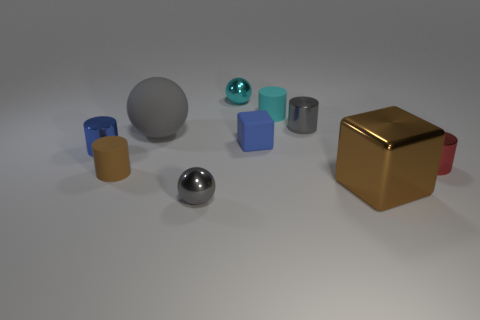What is the size of the matte thing that is on the left side of the small cyan metal ball and to the right of the small brown cylinder?
Your response must be concise. Large. What number of metal things are either large green blocks or small balls?
Offer a very short reply. 2. There is a tiny gray metal object that is on the left side of the cyan rubber cylinder; is it the same shape as the small cyan shiny thing behind the small blue cube?
Make the answer very short. Yes. Is there a large yellow thing that has the same material as the tiny brown thing?
Offer a very short reply. No. What color is the big matte ball?
Your answer should be compact. Gray. There is a block that is behind the small blue metal cylinder; how big is it?
Ensure brevity in your answer.  Small. What number of tiny cylinders are the same color as the tiny block?
Provide a succinct answer. 1. There is a sphere that is in front of the red shiny object; is there a blue thing that is right of it?
Give a very brief answer. Yes. There is a block behind the small blue metal thing; is it the same color as the tiny metallic cylinder that is on the left side of the tiny brown rubber thing?
Offer a very short reply. Yes. There is a block that is the same size as the gray rubber object; what color is it?
Offer a terse response. Brown. 